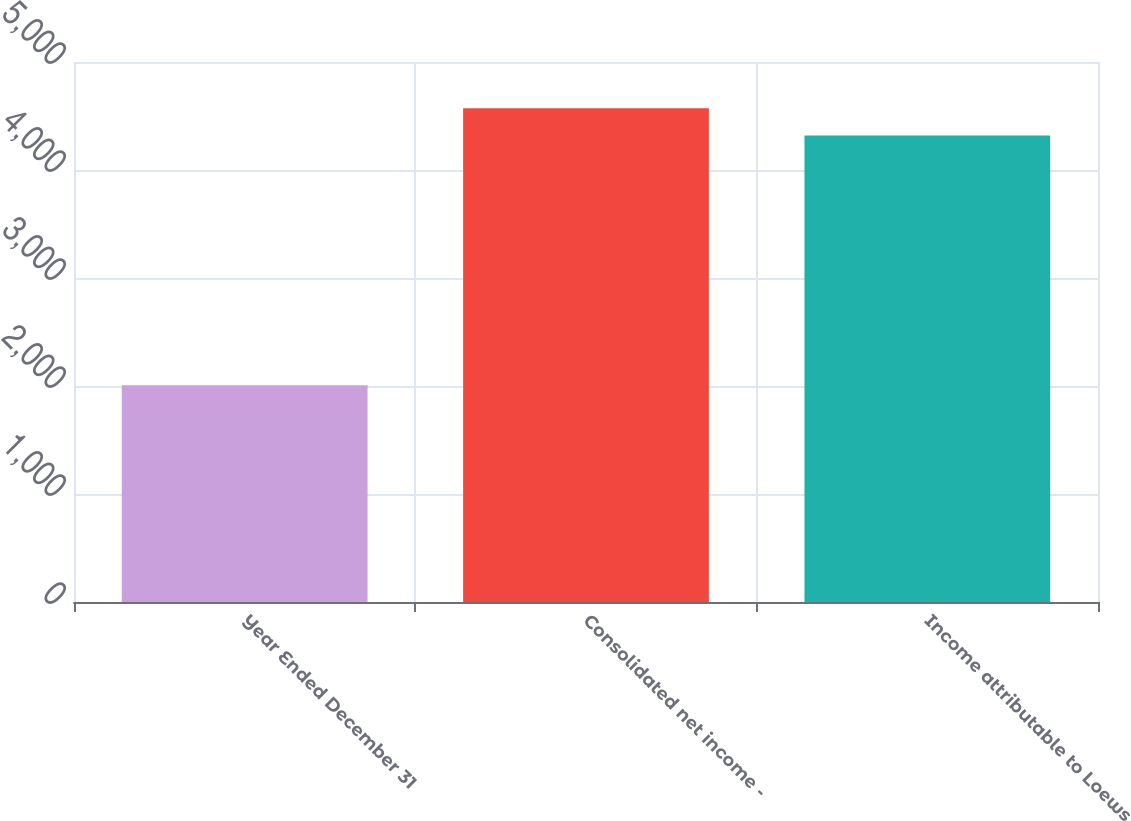Convert chart to OTSL. <chart><loc_0><loc_0><loc_500><loc_500><bar_chart><fcel>Year Ended December 31<fcel>Consolidated net income -<fcel>Income attributable to Loews<nl><fcel>2008<fcel>4571.2<fcel>4319<nl></chart> 